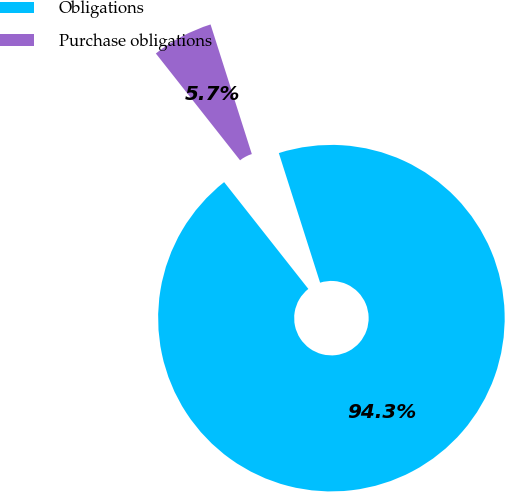Convert chart to OTSL. <chart><loc_0><loc_0><loc_500><loc_500><pie_chart><fcel>Obligations<fcel>Purchase obligations<nl><fcel>94.28%<fcel>5.72%<nl></chart> 